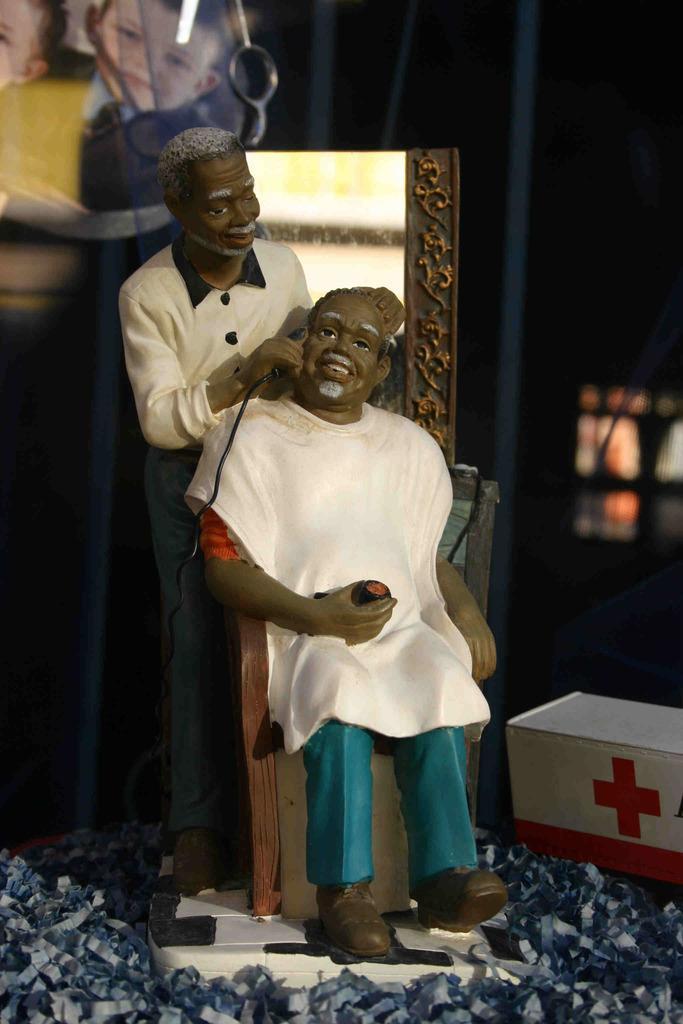Can you describe this image briefly? In this picture we can see a man sitting on a chair and holding an object with his hand and smiling and at the back of him we can see a man standing and holding a machine with his hand, box, mirror and some objects. 